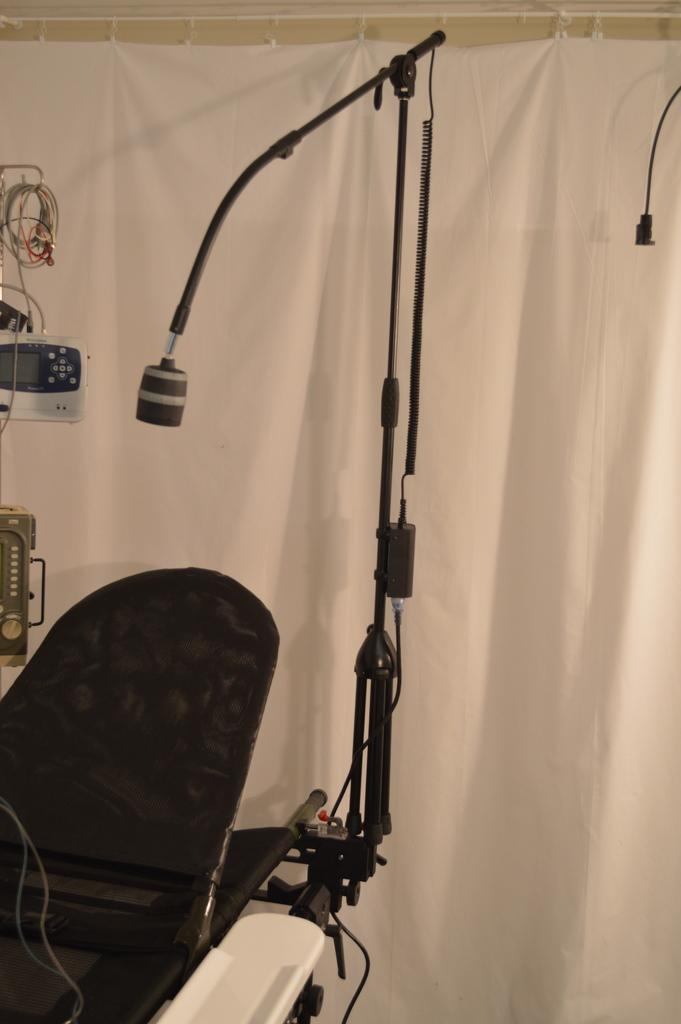What is the main object in the image? There is: There is a microphone in the image. How is the microphone positioned in the image? The microphone is placed on a stand. What is the stand attached to in the image? The stand is attached to a table. What can be seen in the background of the image? There is a white cloth and machines in the background of the image. What type of operation is being performed on the roof in the image? There is no roof or operation present in the image; it only features a microphone, stand, table, white cloth, and machines in the background. 